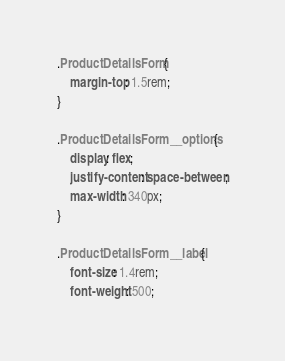Convert code to text. <code><loc_0><loc_0><loc_500><loc_500><_CSS_>.ProductDetailsForm {
    margin-top: 1.5rem;
}

.ProductDetailsForm__options {
    display: flex;
    justify-content: space-between;
    max-width: 340px;
}

.ProductDetailsForm__label {
    font-size: 1.4rem;
    font-weight: 500;</code> 